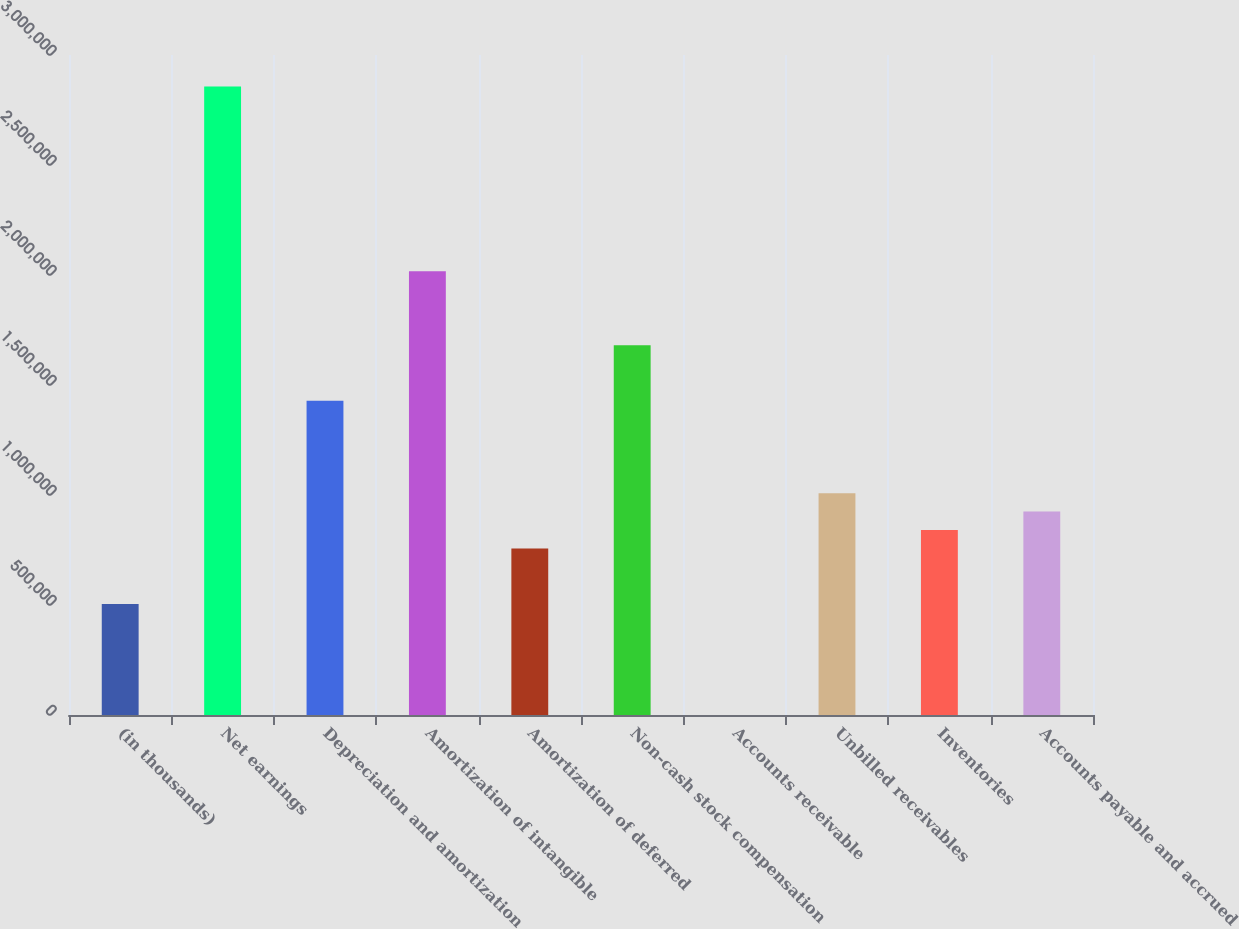Convert chart. <chart><loc_0><loc_0><loc_500><loc_500><bar_chart><fcel>(in thousands)<fcel>Net earnings<fcel>Depreciation and amortization<fcel>Amortization of intangible<fcel>Amortization of deferred<fcel>Non-cash stock compensation<fcel>Accounts receivable<fcel>Unbilled receivables<fcel>Inventories<fcel>Accounts payable and accrued<nl><fcel>504426<fcel>2.85653e+06<fcel>1.42847e+06<fcel>2.01649e+06<fcel>756437<fcel>1.68048e+06<fcel>404<fcel>1.00845e+06<fcel>840441<fcel>924445<nl></chart> 